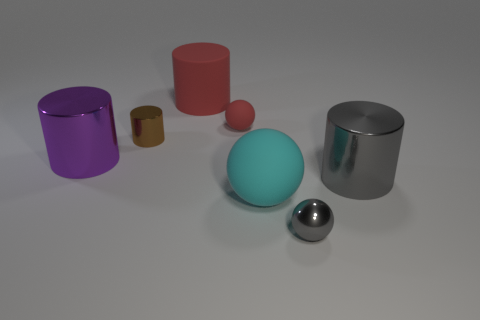Does the large metallic thing that is right of the big purple shiny cylinder have the same color as the small object right of the red rubber sphere?
Your answer should be compact. Yes. There is a large thing that is the same color as the small matte ball; what material is it?
Ensure brevity in your answer.  Rubber. What is the color of the small matte ball?
Ensure brevity in your answer.  Red. There is a large cylinder that is in front of the big metallic thing to the left of the small red thing; what color is it?
Provide a succinct answer. Gray. The large rubber object that is behind the gray shiny thing that is behind the tiny object that is to the right of the cyan object is what shape?
Your answer should be very brief. Cylinder. How many tiny red objects are made of the same material as the large red thing?
Your answer should be compact. 1. How many tiny brown cylinders are in front of the big cylinder right of the red cylinder?
Keep it short and to the point. 0. How many big cylinders are there?
Give a very brief answer. 3. Does the tiny red ball have the same material as the small thing in front of the brown metal object?
Offer a terse response. No. Does the metal cylinder that is on the right side of the small brown thing have the same color as the shiny sphere?
Ensure brevity in your answer.  Yes. 